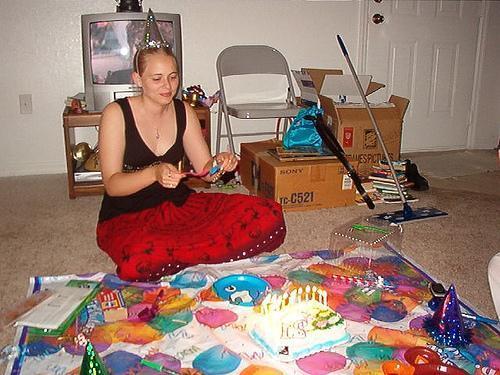How many party hats are in the image?
Give a very brief answer. 3. How many of the people on the bench are holding umbrellas ?
Give a very brief answer. 0. 